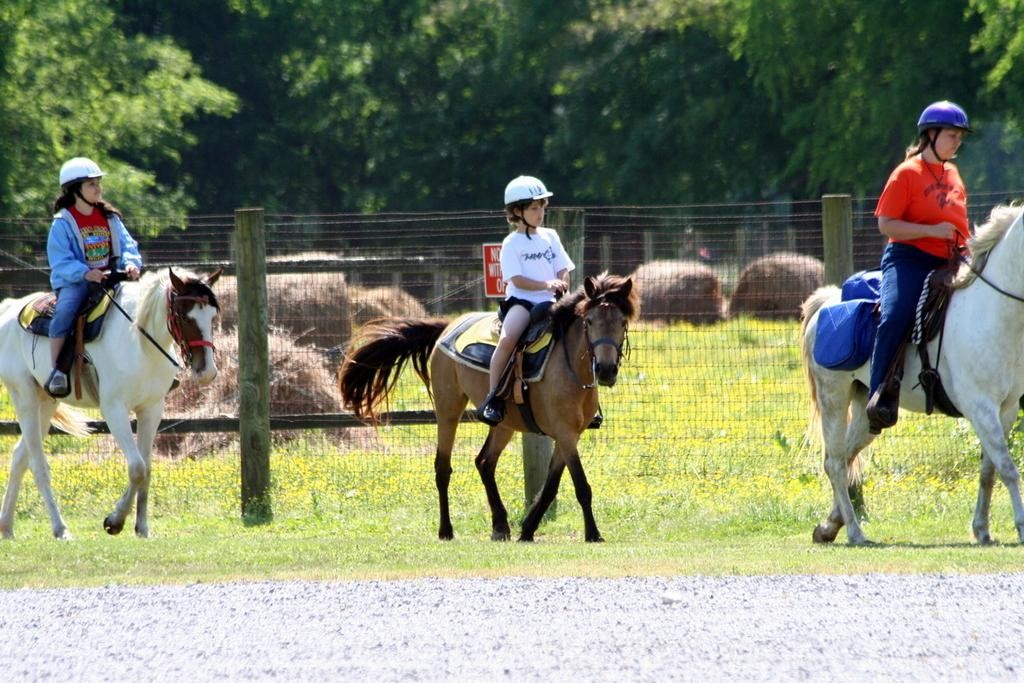What are the two main subjects in the image? There is a little boy riding a brown horse and a girl riding a white horse in the image. What colors are the horses in the image? The boy's horse is brown, and the girl's horse is white. What can be seen in the background of the image? There are trees visible in the background of the image. Can you see a window in the image? There is no window present in the image; it features a little boy riding a brown horse and a girl riding a white horse in an outdoor setting with trees in the background. 